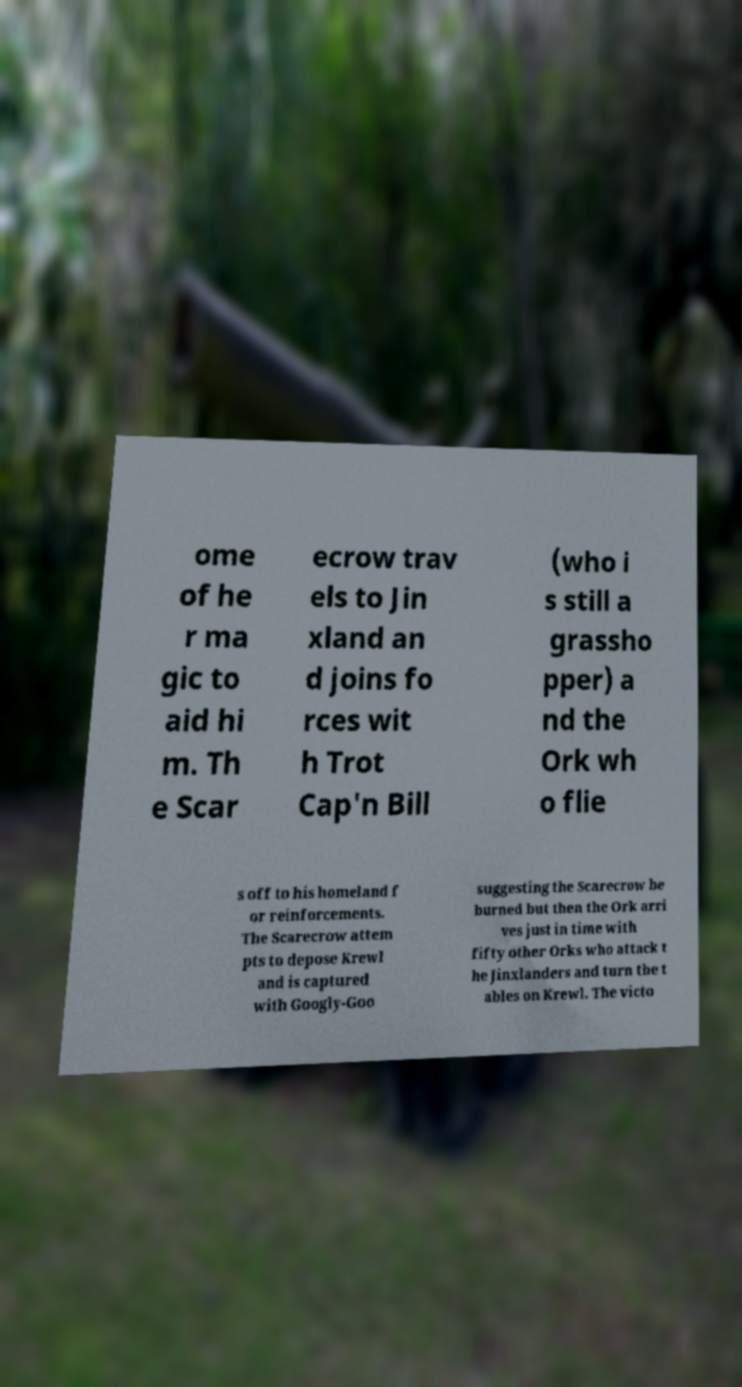Please read and relay the text visible in this image. What does it say? ome of he r ma gic to aid hi m. Th e Scar ecrow trav els to Jin xland an d joins fo rces wit h Trot Cap'n Bill (who i s still a grassho pper) a nd the Ork wh o flie s off to his homeland f or reinforcements. The Scarecrow attem pts to depose Krewl and is captured with Googly-Goo suggesting the Scarecrow be burned but then the Ork arri ves just in time with fifty other Orks who attack t he Jinxlanders and turn the t ables on Krewl. The victo 